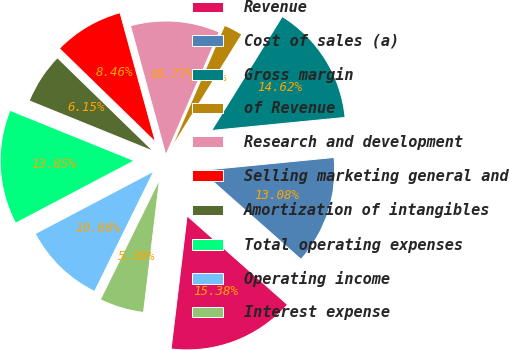Convert chart. <chart><loc_0><loc_0><loc_500><loc_500><pie_chart><fcel>Revenue<fcel>Cost of sales (a)<fcel>Gross margin<fcel>of Revenue<fcel>Research and development<fcel>Selling marketing general and<fcel>Amortization of intangibles<fcel>Total operating expenses<fcel>Operating income<fcel>Interest expense<nl><fcel>15.38%<fcel>13.08%<fcel>14.62%<fcel>2.31%<fcel>10.77%<fcel>8.46%<fcel>6.15%<fcel>13.85%<fcel>10.0%<fcel>5.38%<nl></chart> 